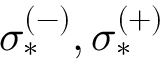<formula> <loc_0><loc_0><loc_500><loc_500>\sigma _ { * } ^ { ( - ) } , \sigma _ { * } ^ { ( + ) }</formula> 